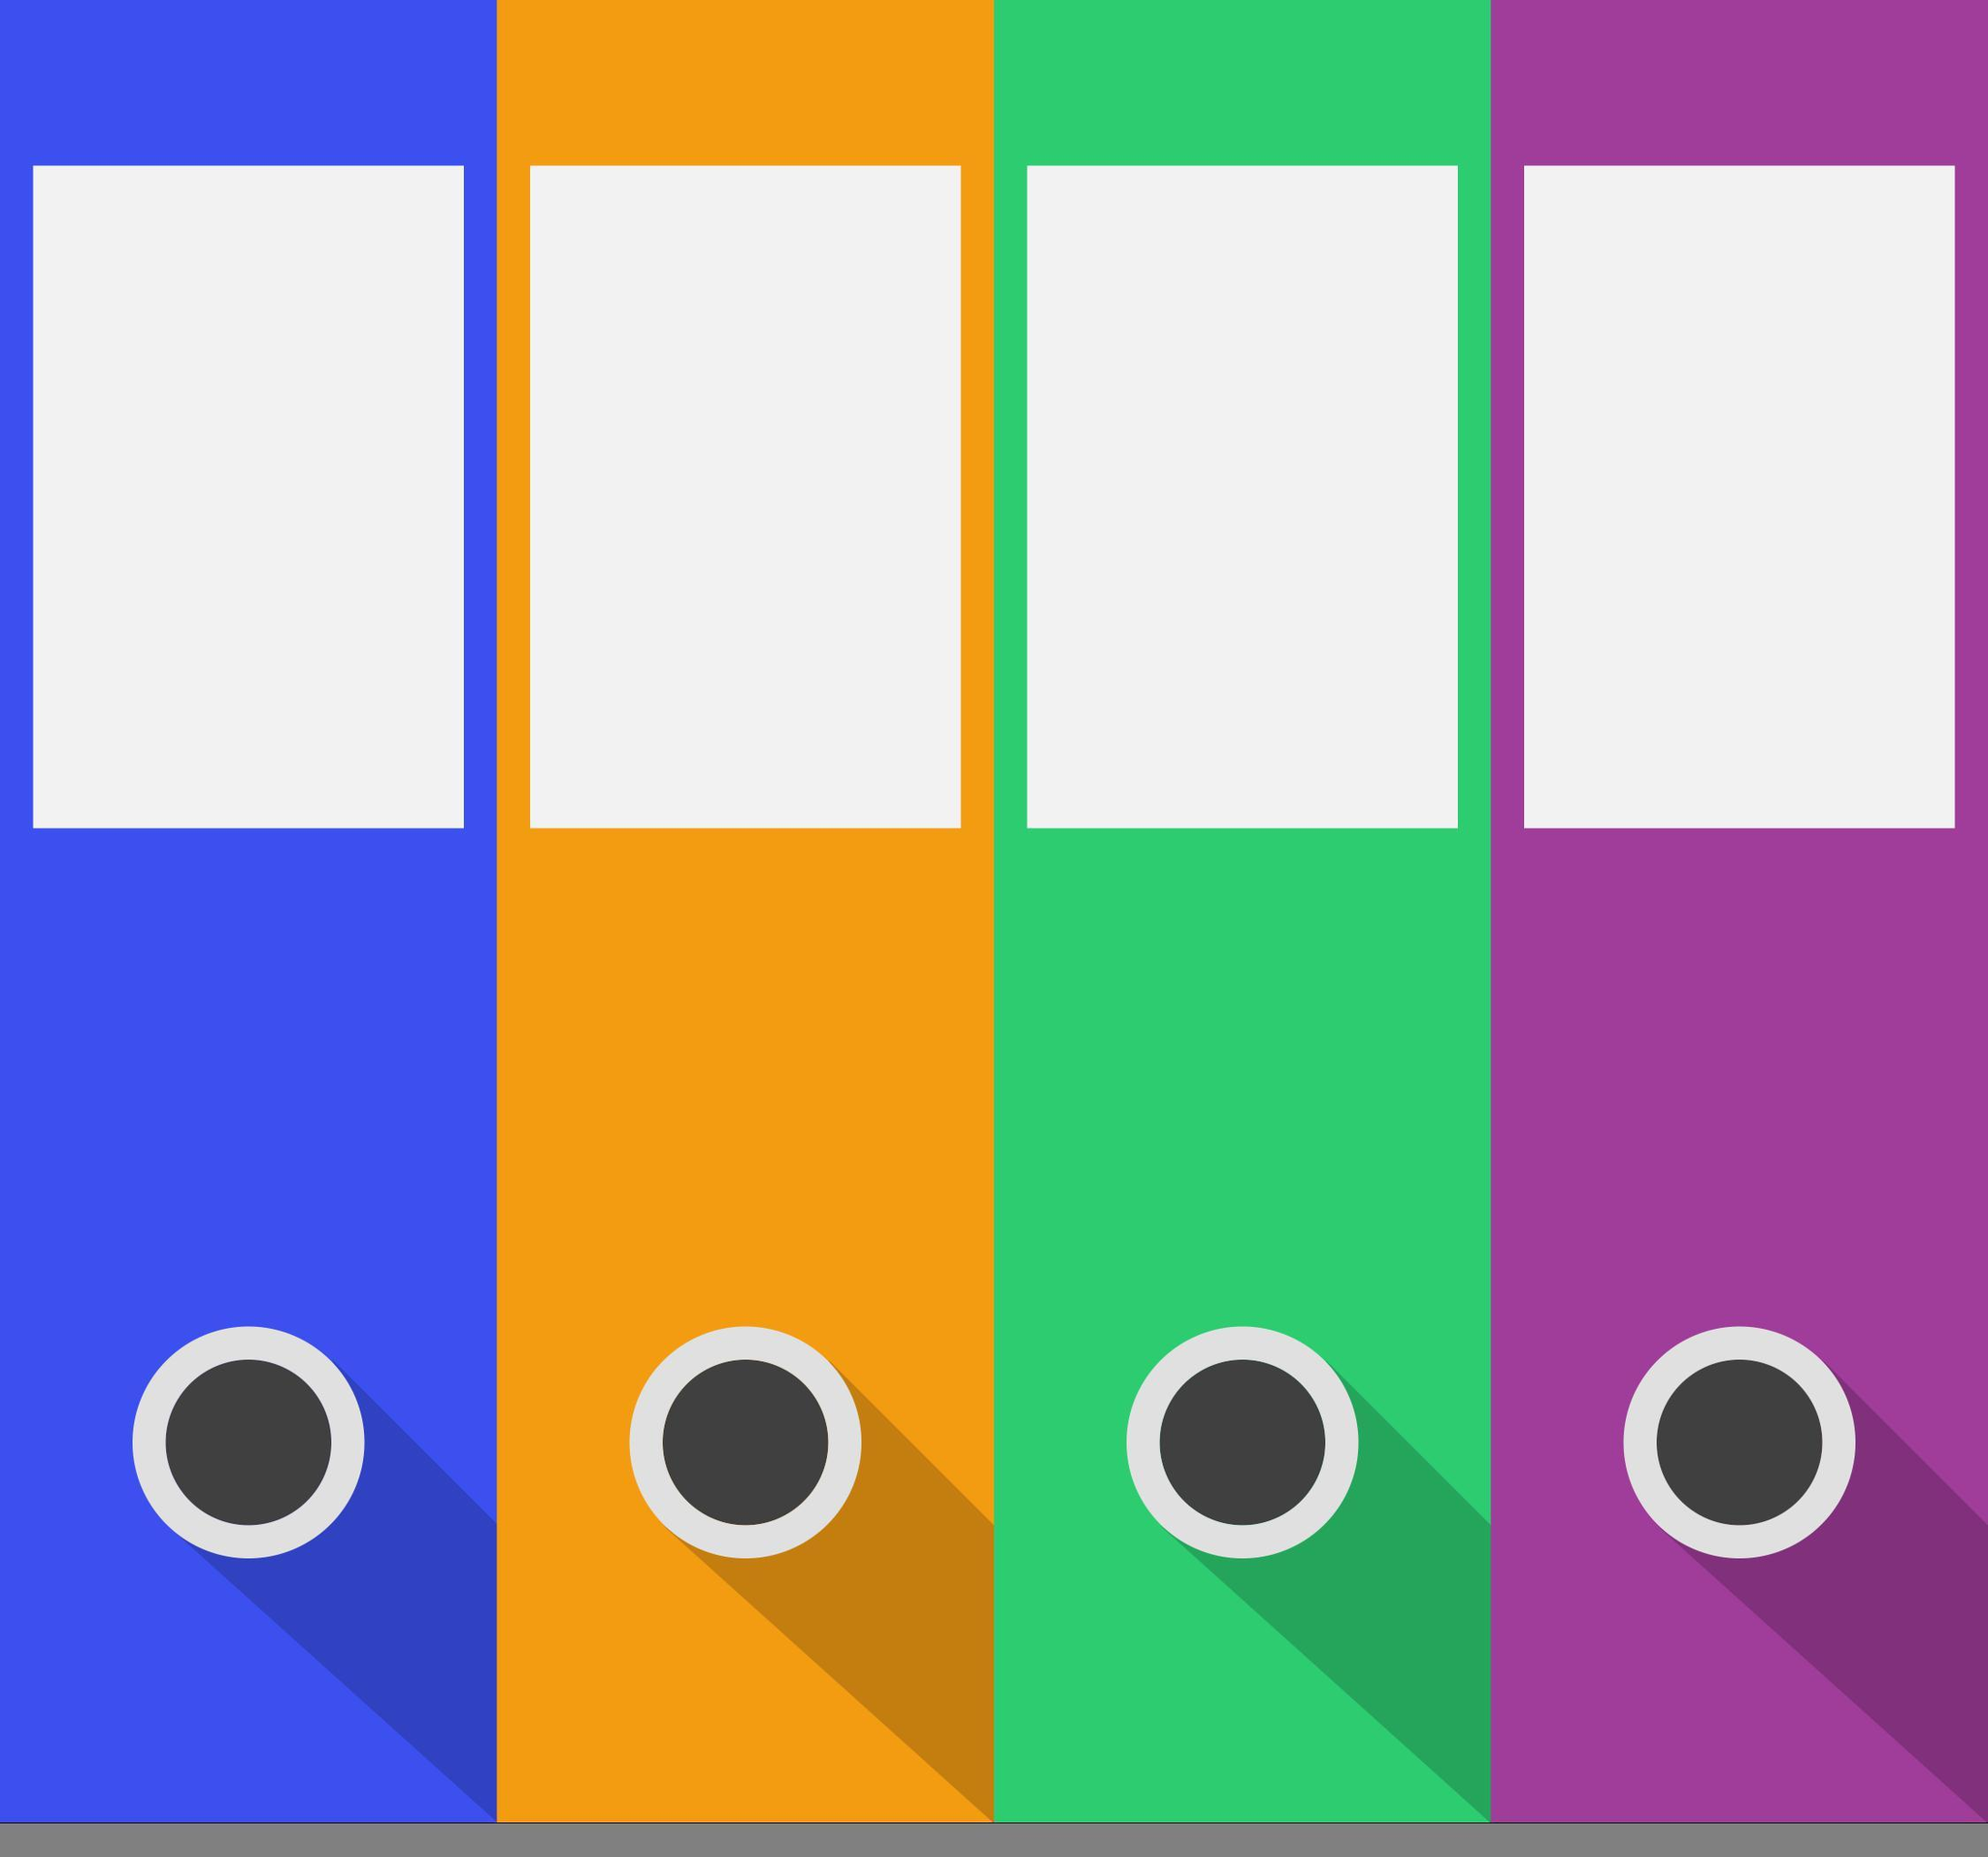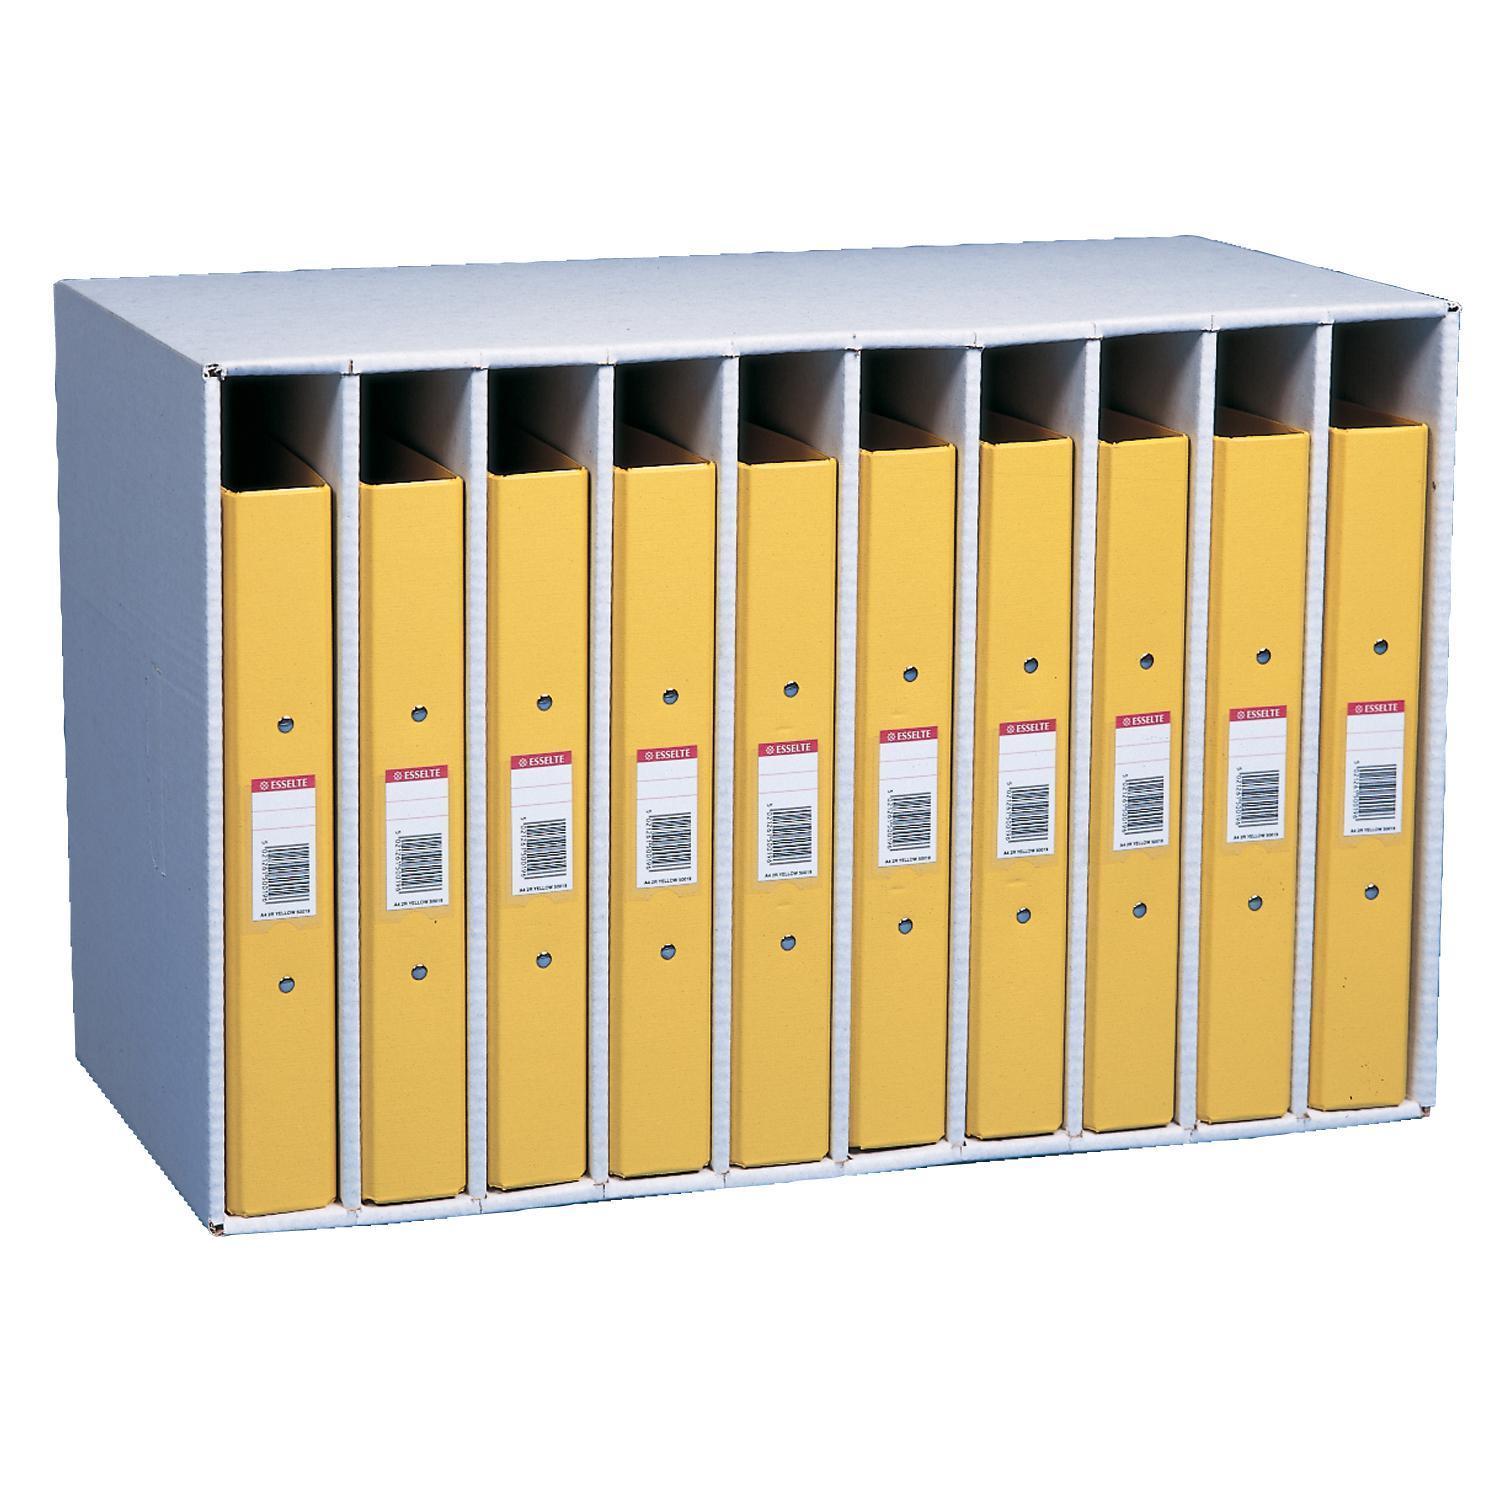The first image is the image on the left, the second image is the image on the right. For the images shown, is this caption "There are four storage books of the same color in the left image." true? Answer yes or no. No. 